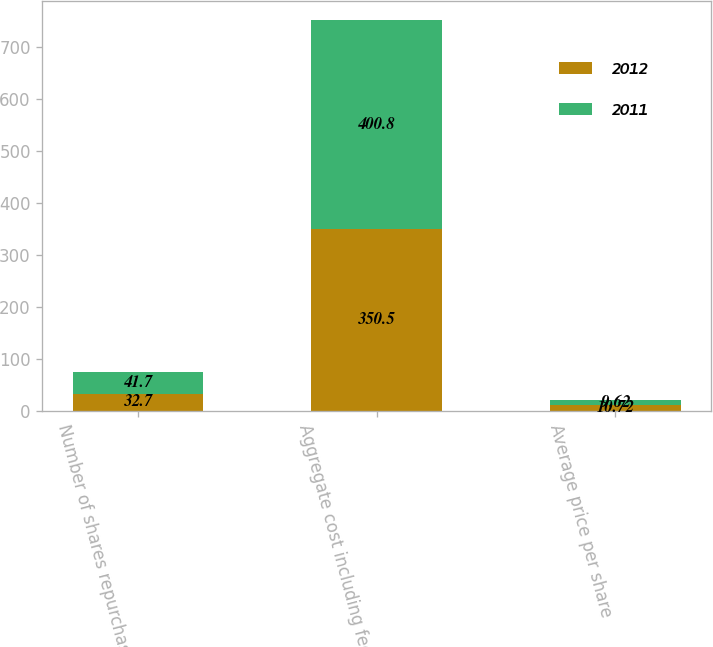Convert chart. <chart><loc_0><loc_0><loc_500><loc_500><stacked_bar_chart><ecel><fcel>Number of shares repurchased<fcel>Aggregate cost including fees<fcel>Average price per share<nl><fcel>2012<fcel>32.7<fcel>350.5<fcel>10.72<nl><fcel>2011<fcel>41.7<fcel>400.8<fcel>9.62<nl></chart> 